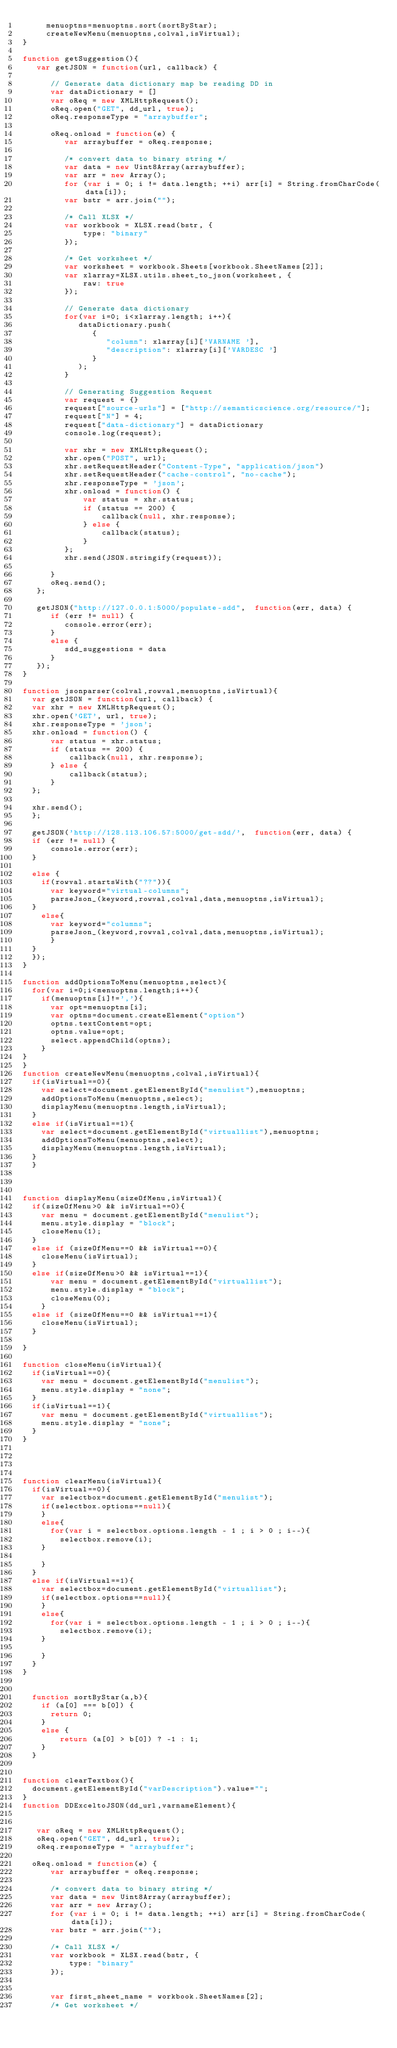Convert code to text. <code><loc_0><loc_0><loc_500><loc_500><_JavaScript_>     menuoptns=menuoptns.sort(sortByStar);
     createNewMenu(menuoptns,colval,isVirtual);
}

function getSuggestion(){
   var getJSON = function(url, callback) {

      // Generate data dictionary map be reading DD in
      var dataDictionary = []
      var oReq = new XMLHttpRequest();
      oReq.open("GET", dd_url, true);
      oReq.responseType = "arraybuffer";

      oReq.onload = function(e) {
         var arraybuffer = oReq.response;

         /* convert data to binary string */
         var data = new Uint8Array(arraybuffer);
         var arr = new Array();
         for (var i = 0; i != data.length; ++i) arr[i] = String.fromCharCode(data[i]);
         var bstr = arr.join("");

         /* Call XLSX */
         var workbook = XLSX.read(bstr, {
             type: "binary"
         });

         /* Get worksheet */
         var worksheet = workbook.Sheets[workbook.SheetNames[2]];
         var xlarray=XLSX.utils.sheet_to_json(worksheet, {
             raw: true
         });

         // Generate data dictionary
         for(var i=0; i<xlarray.length; i++){
            dataDictionary.push(
               {
                  "column": xlarray[i]['VARNAME '],
                  "description": xlarray[i]['VARDESC ']
               }
            );
         }

         // Generating Suggestion Request
         var request = {}
         request["source-urls"] = ["http://semanticscience.org/resource/"];
         request["N"] = 4;
         request["data-dictionary"] = dataDictionary
         console.log(request);

         var xhr = new XMLHttpRequest();
         xhr.open("POST", url);
         xhr.setRequestHeader("Content-Type", "application/json")
         xhr.setRequestHeader("cache-control", "no-cache");
         xhr.responseType = 'json';
         xhr.onload = function() {
             var status = xhr.status;
             if (status == 200) {
                 callback(null, xhr.response);
             } else {
                 callback(status);
             }
         };
         xhr.send(JSON.stringify(request));

      }
      oReq.send();
   };

   getJSON("http://127.0.0.1:5000/populate-sdd",  function(err, data) {
      if (err != null) {
         console.error(err);
      }
      else {
         sdd_suggestions = data
      }
   });
}

function jsonparser(colval,rowval,menuoptns,isVirtual){
  var getJSON = function(url, callback) {
  var xhr = new XMLHttpRequest();
  xhr.open('GET', url, true);
  xhr.responseType = 'json';
  xhr.onload = function() {
      var status = xhr.status;
      if (status == 200) {
          callback(null, xhr.response);
      } else {
          callback(status);
      }
  };

  xhr.send();
  };

  getJSON('http://128.113.106.57:5000/get-sdd/',  function(err, data) {
  if (err != null) {
      console.error(err);
  }

  else {
    if(rowval.startsWith("??")){
      var keyword="virtual-columns";
      parseJson_(keyword,rowval,colval,data,menuoptns,isVirtual);
  }
    else{
      var keyword="columns";
      parseJson_(keyword,rowval,colval,data,menuoptns,isVirtual);
      }
  }
  });
}

function addOptionsToMenu(menuoptns,select){
  for(var i=0;i<menuoptns.length;i++){
    if(menuoptns[i]!=','){
      var opt=menuoptns[i];
      var optns=document.createElement("option")
      optns.textContent=opt;
      optns.value=opt;
      select.appendChild(optns);
    }
}
}
function createNewMenu(menuoptns,colval,isVirtual){
  if(isVirtual==0){
    var select=document.getElementById("menulist"),menuoptns;
    addOptionsToMenu(menuoptns,select);
    displayMenu(menuoptns.length,isVirtual);
  }
  else if(isVirtual==1){
    var select=document.getElementById("virtuallist"),menuoptns;
    addOptionsToMenu(menuoptns,select);
    displayMenu(menuoptns.length,isVirtual);
  }
  }



function displayMenu(sizeOfMenu,isVirtual){
  if(sizeOfMenu>0 && isVirtual==0){
    var menu = document.getElementById("menulist");
    menu.style.display = "block";
    closeMenu(1);
  }
  else if (sizeOfMenu==0 && isVirtual==0){
    closeMenu(isVirtual);
  }
  else if(sizeOfMenu>0 && isVirtual==1){
      var menu = document.getElementById("virtuallist");
      menu.style.display = "block";
      closeMenu(0);
    }
  else if (sizeOfMenu==0 && isVirtual==1){
    closeMenu(isVirtual);
  }

}

function closeMenu(isVirtual){
  if(isVirtual==0){
    var menu = document.getElementById("menulist");
    menu.style.display = "none";
  }
  if(isVirtual==1){
    var menu = document.getElementById("virtuallist");
    menu.style.display = "none";
  }
}




function clearMenu(isVirtual){
  if(isVirtual==0){
    var selectbox=document.getElementById("menulist");
    if(selectbox.options==null){
    }
    else{
      for(var i = selectbox.options.length - 1 ; i > 0 ; i--){
        selectbox.remove(i);
    }

    }
  }
  else if(isVirtual==1){
    var selectbox=document.getElementById("virtuallist");
    if(selectbox.options==null){
    }
    else{
      for(var i = selectbox.options.length - 1 ; i > 0 ; i--){
        selectbox.remove(i);
    }

    }
  }
}


  function sortByStar(a,b){
    if (a[0] === b[0]) {
      return 0;
    }
    else {
        return (a[0] > b[0]) ? -1 : 1;
    }
  }


function clearTextbox(){
  document.getElementById("varDescription").value="";
}
function DDExceltoJSON(dd_url,varnameElement){


   var oReq = new XMLHttpRequest();
   oReq.open("GET", dd_url, true);
   oReq.responseType = "arraybuffer";

  oReq.onload = function(e) {
      var arraybuffer = oReq.response;

      /* convert data to binary string */
      var data = new Uint8Array(arraybuffer);
      var arr = new Array();
      for (var i = 0; i != data.length; ++i) arr[i] = String.fromCharCode(data[i]);
      var bstr = arr.join("");

      /* Call XLSX */
      var workbook = XLSX.read(bstr, {
          type: "binary"
      });


      var first_sheet_name = workbook.SheetNames[2];
      /* Get worksheet */</code> 